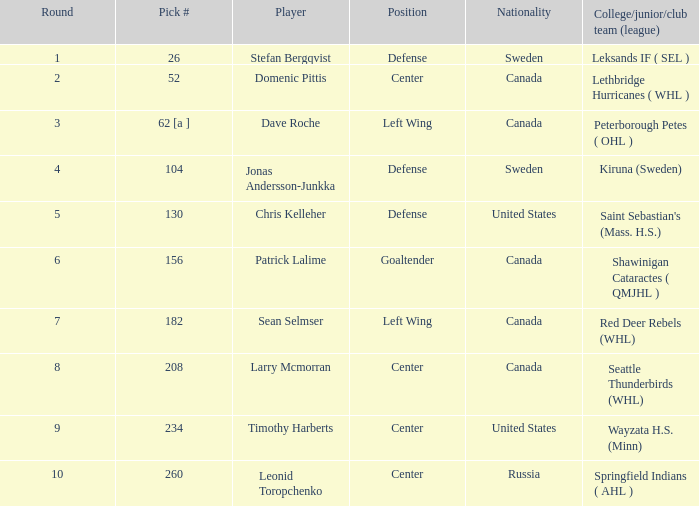For the player selected with the 130th pick in the league, what is their college, junior, or club team affiliation? Saint Sebastian's (Mass. H.S.). 